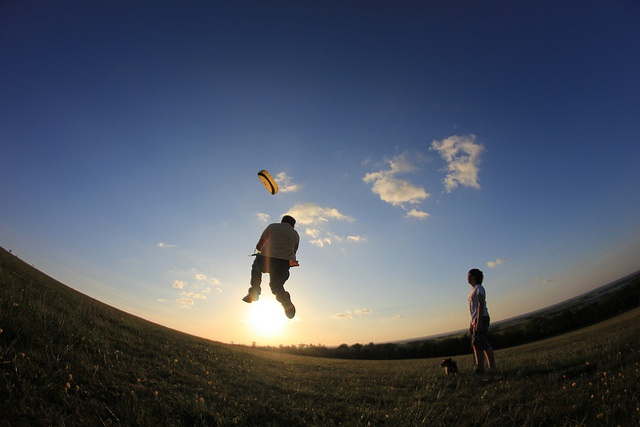Describe the objects in this image and their specific colors. I can see people in navy, black, maroon, and gray tones, people in navy, black, maroon, gray, and tan tones, kite in navy, orange, olive, black, and maroon tones, and dog in navy, black, maroon, and brown tones in this image. 